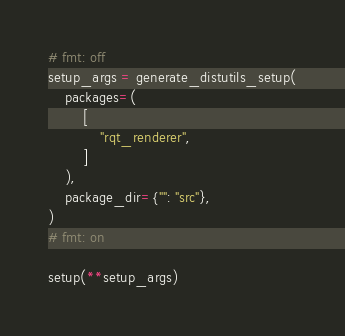<code> <loc_0><loc_0><loc_500><loc_500><_Python_># fmt: off
setup_args = generate_distutils_setup(
    packages=(
        [
            "rqt_renderer",
        ]
    ),
    package_dir={"": "src"},
)
# fmt: on

setup(**setup_args)
</code> 